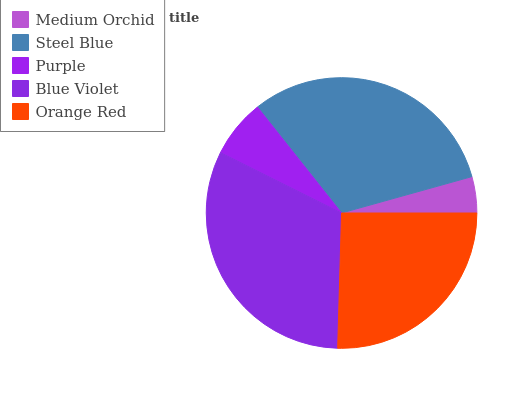Is Medium Orchid the minimum?
Answer yes or no. Yes. Is Blue Violet the maximum?
Answer yes or no. Yes. Is Steel Blue the minimum?
Answer yes or no. No. Is Steel Blue the maximum?
Answer yes or no. No. Is Steel Blue greater than Medium Orchid?
Answer yes or no. Yes. Is Medium Orchid less than Steel Blue?
Answer yes or no. Yes. Is Medium Orchid greater than Steel Blue?
Answer yes or no. No. Is Steel Blue less than Medium Orchid?
Answer yes or no. No. Is Orange Red the high median?
Answer yes or no. Yes. Is Orange Red the low median?
Answer yes or no. Yes. Is Medium Orchid the high median?
Answer yes or no. No. Is Purple the low median?
Answer yes or no. No. 